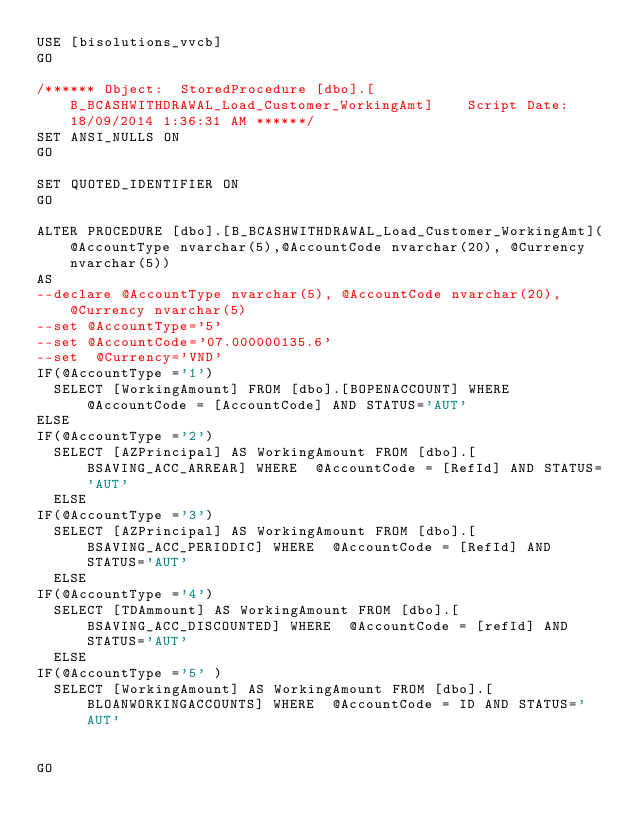<code> <loc_0><loc_0><loc_500><loc_500><_SQL_>USE [bisolutions_vvcb]
GO

/****** Object:  StoredProcedure [dbo].[B_BCASHWITHDRAWAL_Load_Customer_WorkingAmt]    Script Date: 18/09/2014 1:36:31 AM ******/
SET ANSI_NULLS ON
GO

SET QUOTED_IDENTIFIER ON
GO

ALTER PROCEDURE [dbo].[B_BCASHWITHDRAWAL_Load_Customer_WorkingAmt](@AccountType nvarchar(5),@AccountCode nvarchar(20), @Currency nvarchar(5))
AS 
--declare @AccountType nvarchar(5), @AccountCode nvarchar(20), @Currency nvarchar(5)
--set @AccountType='5'
--set @AccountCode='07.000000135.6'
--set  @Currency='VND'
IF(@AccountType ='1')
	SELECT [WorkingAmount] FROM [dbo].[BOPENACCOUNT] WHERE  @AccountCode = [AccountCode] AND STATUS='AUT'
ELSE 
IF(@AccountType ='2')
	SELECT [AZPrincipal] AS WorkingAmount FROM [dbo].[BSAVING_ACC_ARREAR] WHERE  @AccountCode = [RefId] AND STATUS='AUT'
	ELSE 
IF(@AccountType ='3')
	SELECT [AZPrincipal] AS WorkingAmount FROM [dbo].[BSAVING_ACC_PERIODIC] WHERE  @AccountCode = [RefId] AND STATUS='AUT'
	ELSE 
IF(@AccountType ='4')
	SELECT [TDAmmount] AS WorkingAmount FROM [dbo].[BSAVING_ACC_DISCOUNTED] WHERE  @AccountCode = [refId] AND STATUS='AUT'   
	ELSE 
IF(@AccountType ='5' )
	SELECT [WorkingAmount] AS WorkingAmount FROM [dbo].[BLOANWORKINGACCOUNTS] WHERE  @AccountCode = ID AND STATUS='AUT'  


GO


</code> 